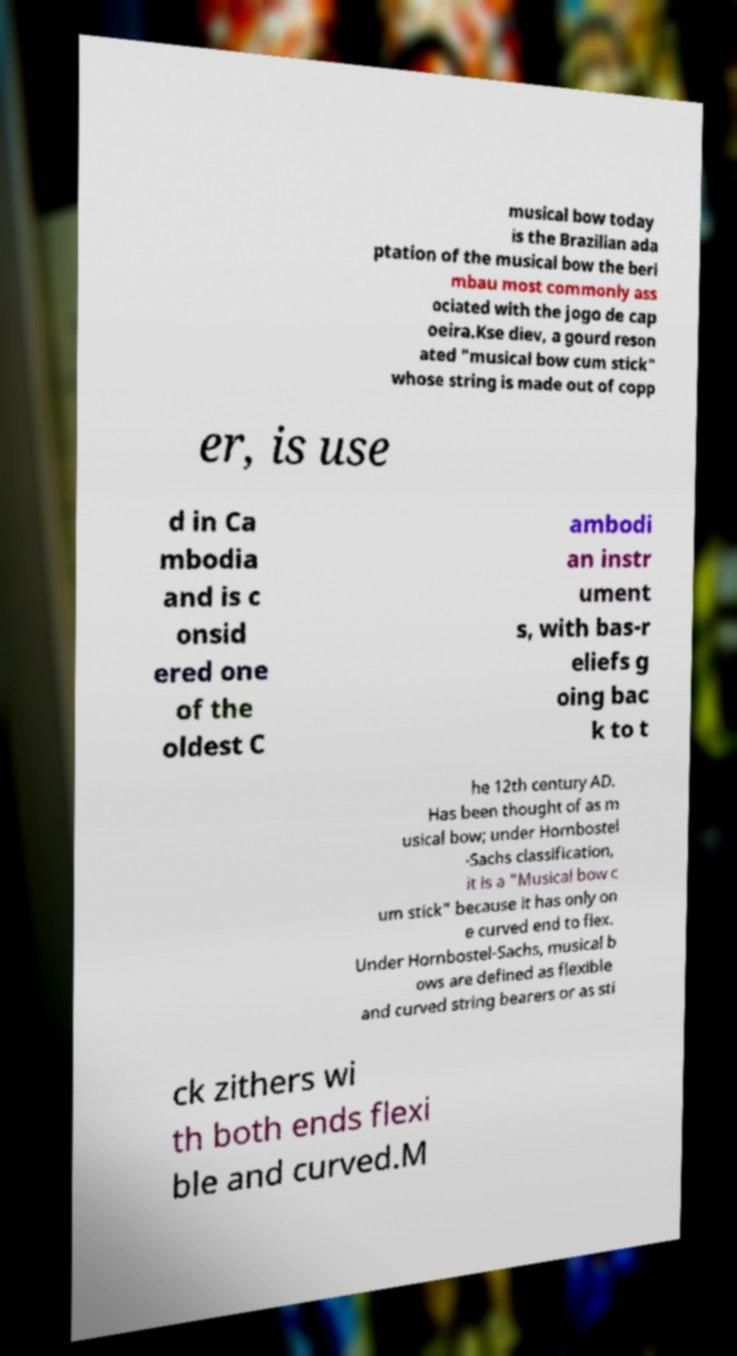There's text embedded in this image that I need extracted. Can you transcribe it verbatim? musical bow today is the Brazilian ada ptation of the musical bow the beri mbau most commonly ass ociated with the jogo de cap oeira.Kse diev, a gourd reson ated "musical bow cum stick" whose string is made out of copp er, is use d in Ca mbodia and is c onsid ered one of the oldest C ambodi an instr ument s, with bas-r eliefs g oing bac k to t he 12th century AD. Has been thought of as m usical bow; under Hornbostel -Sachs classification, it is a "Musical bow c um stick" because it has only on e curved end to flex. Under Hornbostel-Sachs, musical b ows are defined as flexible and curved string bearers or as sti ck zithers wi th both ends flexi ble and curved.M 